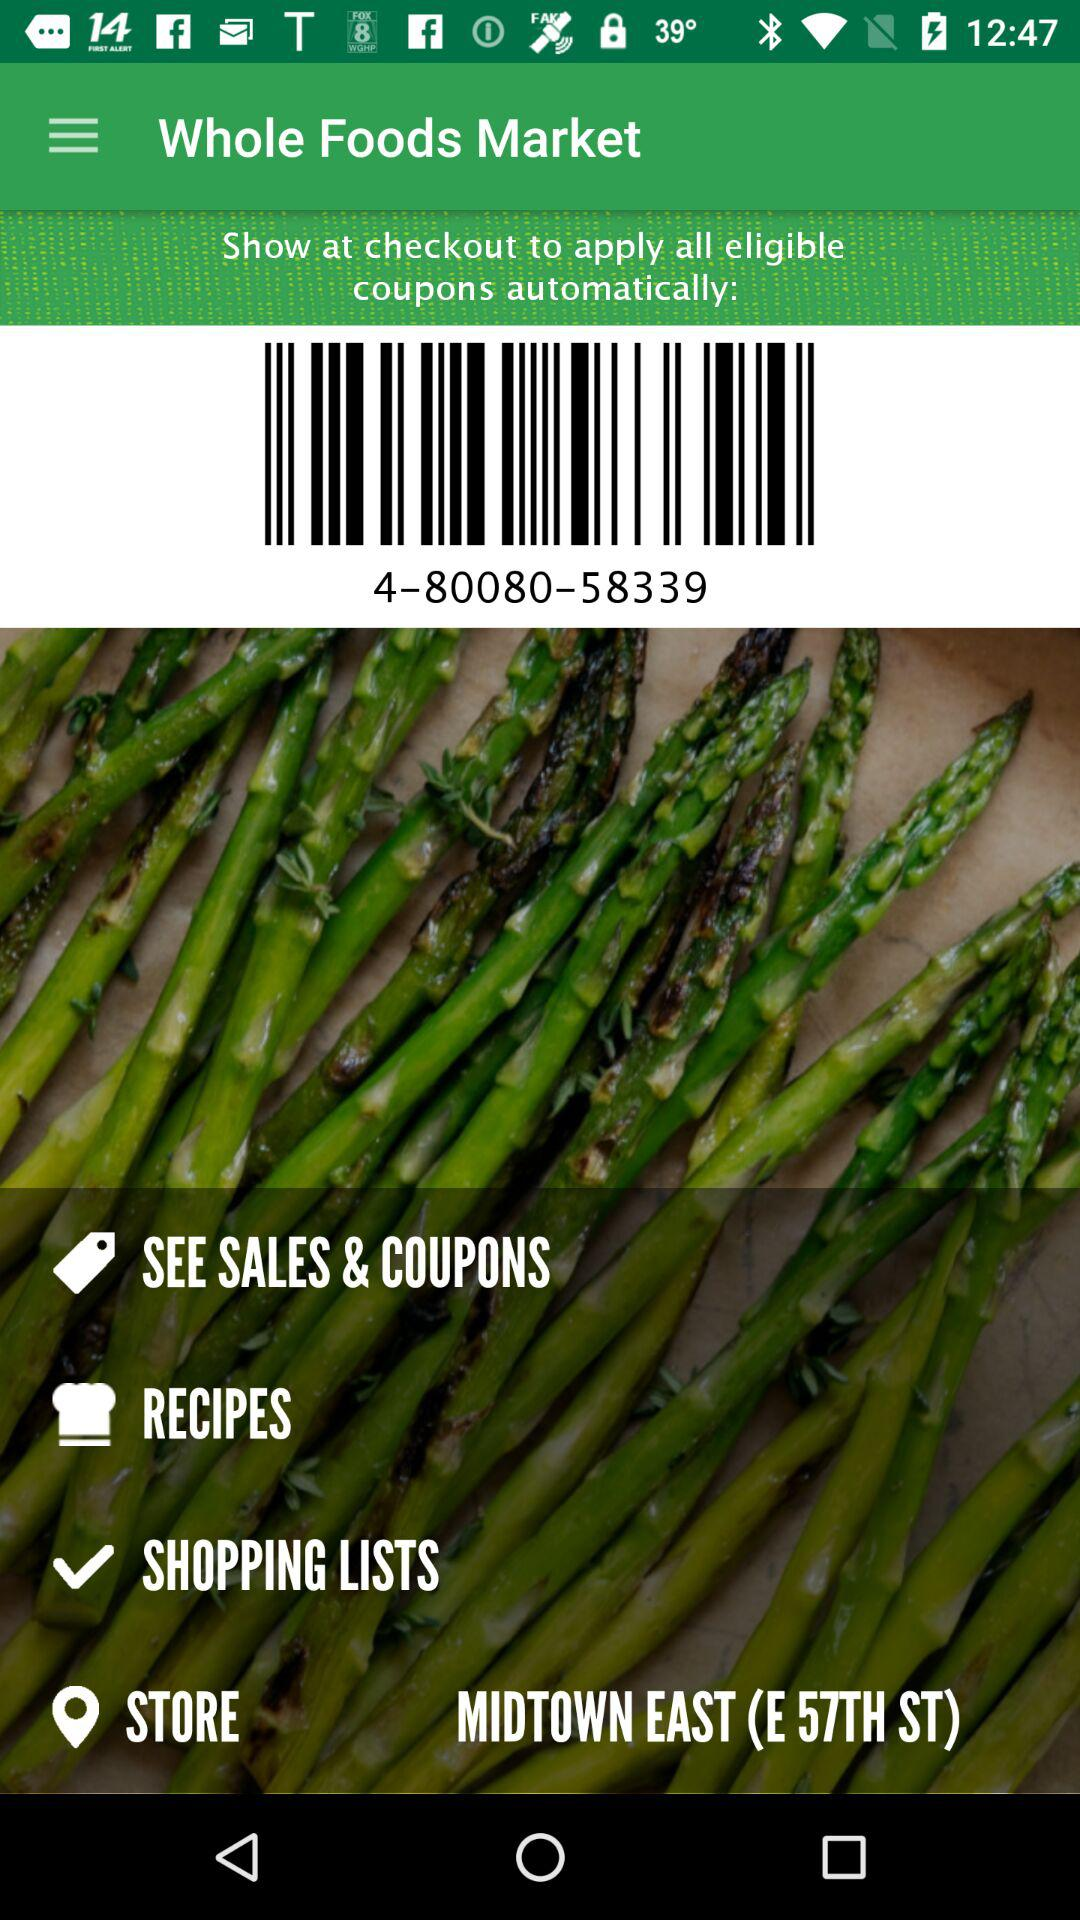What are the barcode numbers given on the screen? The given barcode number is 4-80080-58339. 